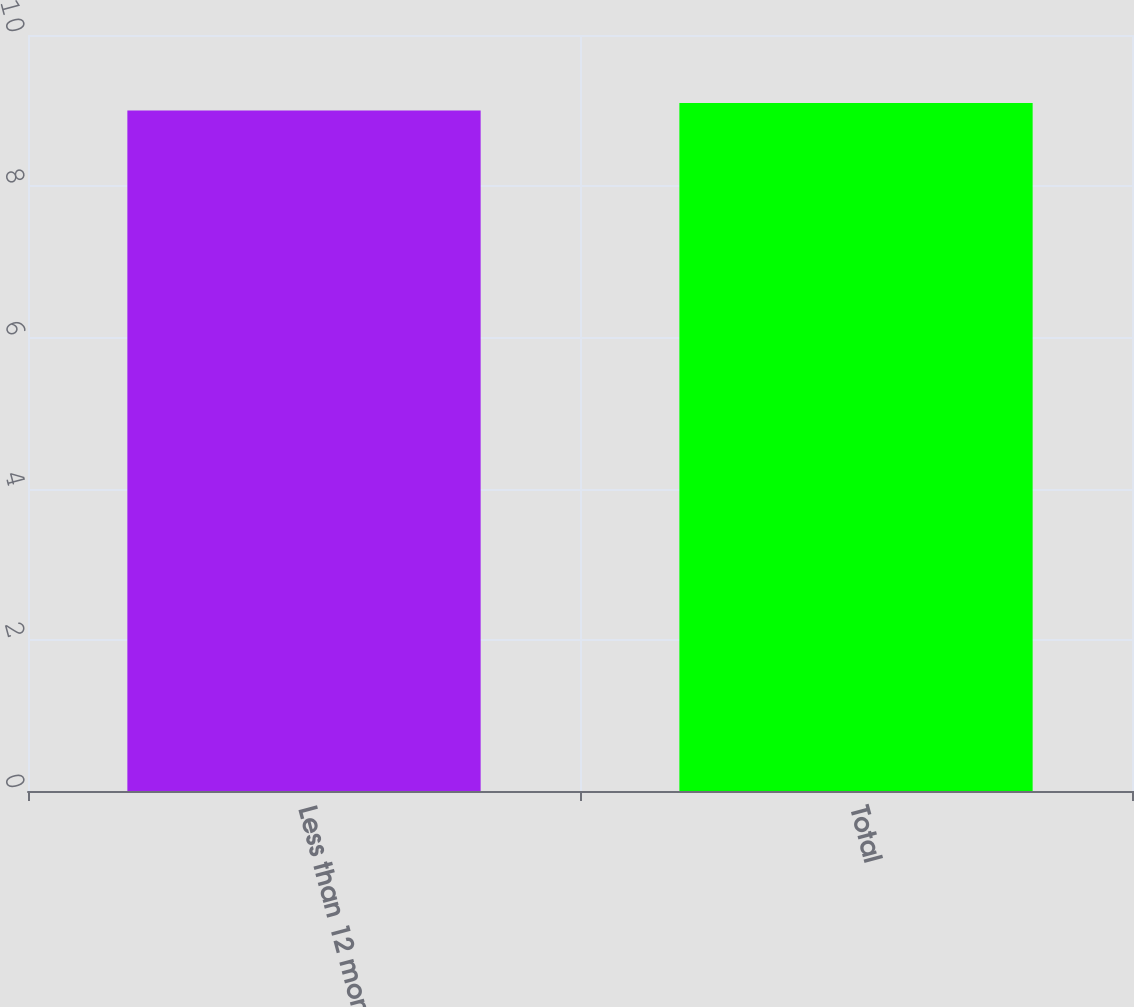Convert chart. <chart><loc_0><loc_0><loc_500><loc_500><bar_chart><fcel>Less than 12 months<fcel>Total<nl><fcel>9<fcel>9.1<nl></chart> 